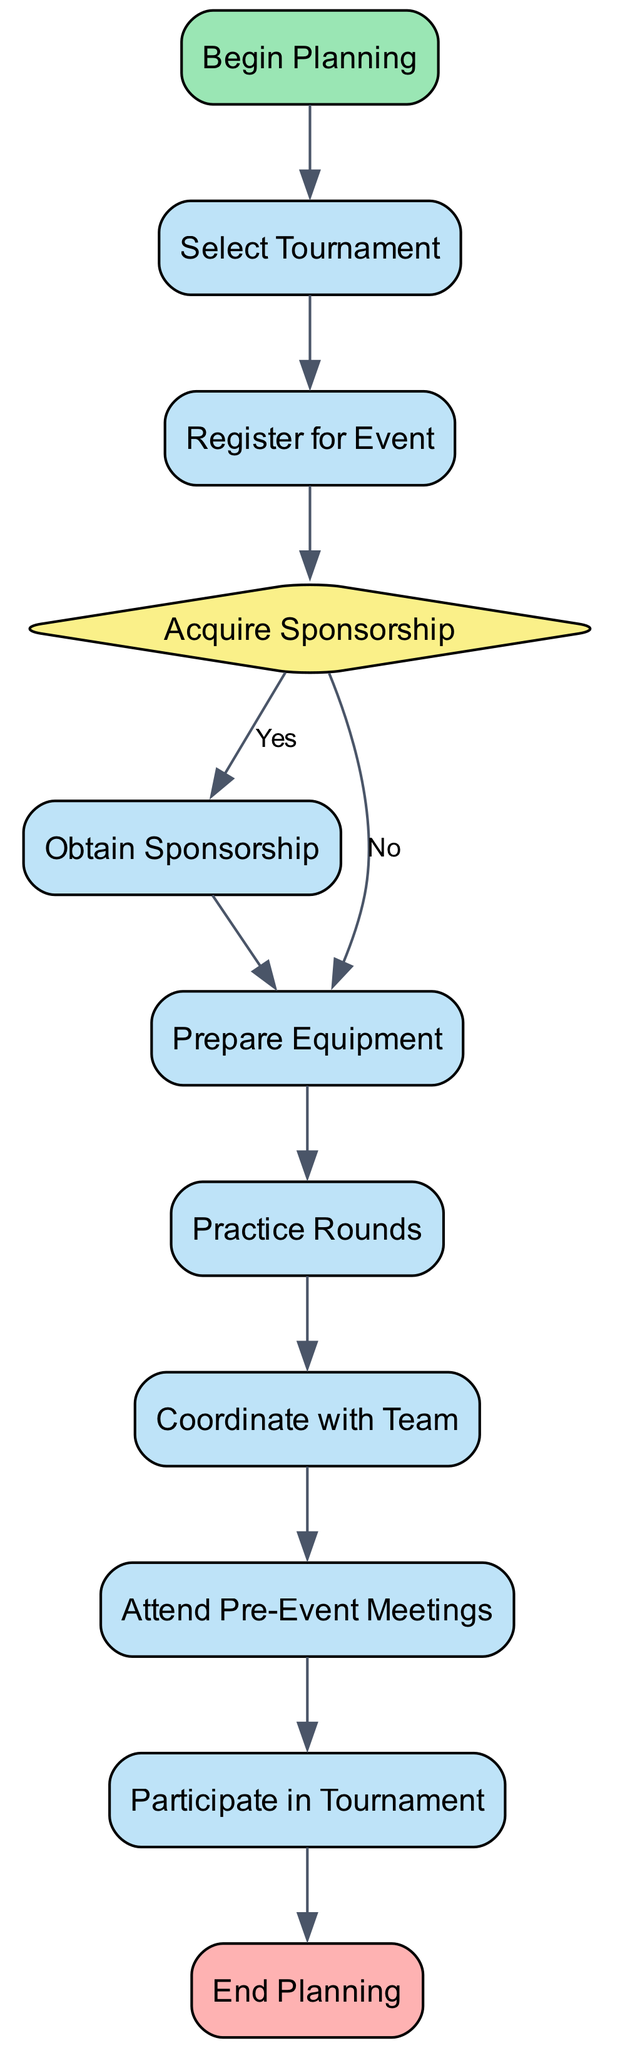What is the first action to take in this activity diagram? The diagram starts with the "Begin Planning" node, and the first action that follows is "Select Tournament." This is determined by following the first transition from the start node to the select tournament node.
Answer: Select Tournament How many actions are there in this diagram? The diagram contains eight action nodes, which include "Select Tournament," "Register for Event," "Obtain Sponsorship," "Prepare Equipment," "Practice Rounds," "Coordinate with Team," "Attend Pre-Event Meetings," and "Participate in Tournament." By counting each action node in the elements section, we reach this total.
Answer: Eight Is obtaining sponsorship conditional? Yes, obtaining sponsorship is conditional based on whether a sponsor is required. This is indicated by the decision node "Acquire Sponsorship," which leads to two outcomes: if "Yes," the next action is "Obtain Sponsorship," and if "No," it proceeds directly to "Prepare Equipment."
Answer: Yes What action follows after attending pre-event meetings? After completing the action "Attend Pre-Event Meetings," the next action is "Participate in Tournament." This is the last action before ending the planning process, as shown by the transition from the pre-event meetings action to the participation action.
Answer: Participate in Tournament What does the decision node "Acquire Sponsorship" determine? The decision node "Acquire Sponsorship" determines whether obtaining sponsorship is necessary for the tournament preparations. It leads to either the action of "Obtain Sponsorship" if the response is "Yes," or directly leads to "Prepare Equipment" if the response is "No."
Answer: Whether sponsorship is required 